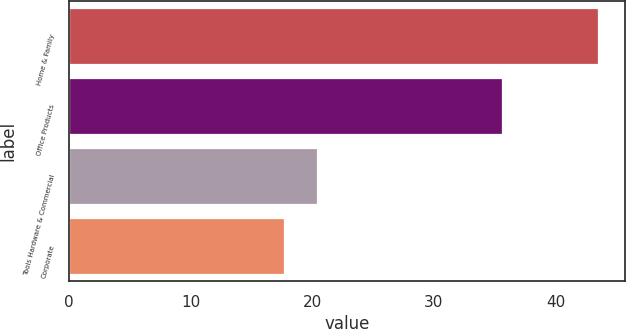Convert chart to OTSL. <chart><loc_0><loc_0><loc_500><loc_500><bar_chart><fcel>Home & Family<fcel>Office Products<fcel>Tools Hardware & Commercial<fcel>Corporate<nl><fcel>43.5<fcel>35.6<fcel>20.4<fcel>17.7<nl></chart> 